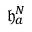Convert formula to latex. <formula><loc_0><loc_0><loc_500><loc_500>\mathfrak { h } _ { a } ^ { N }</formula> 